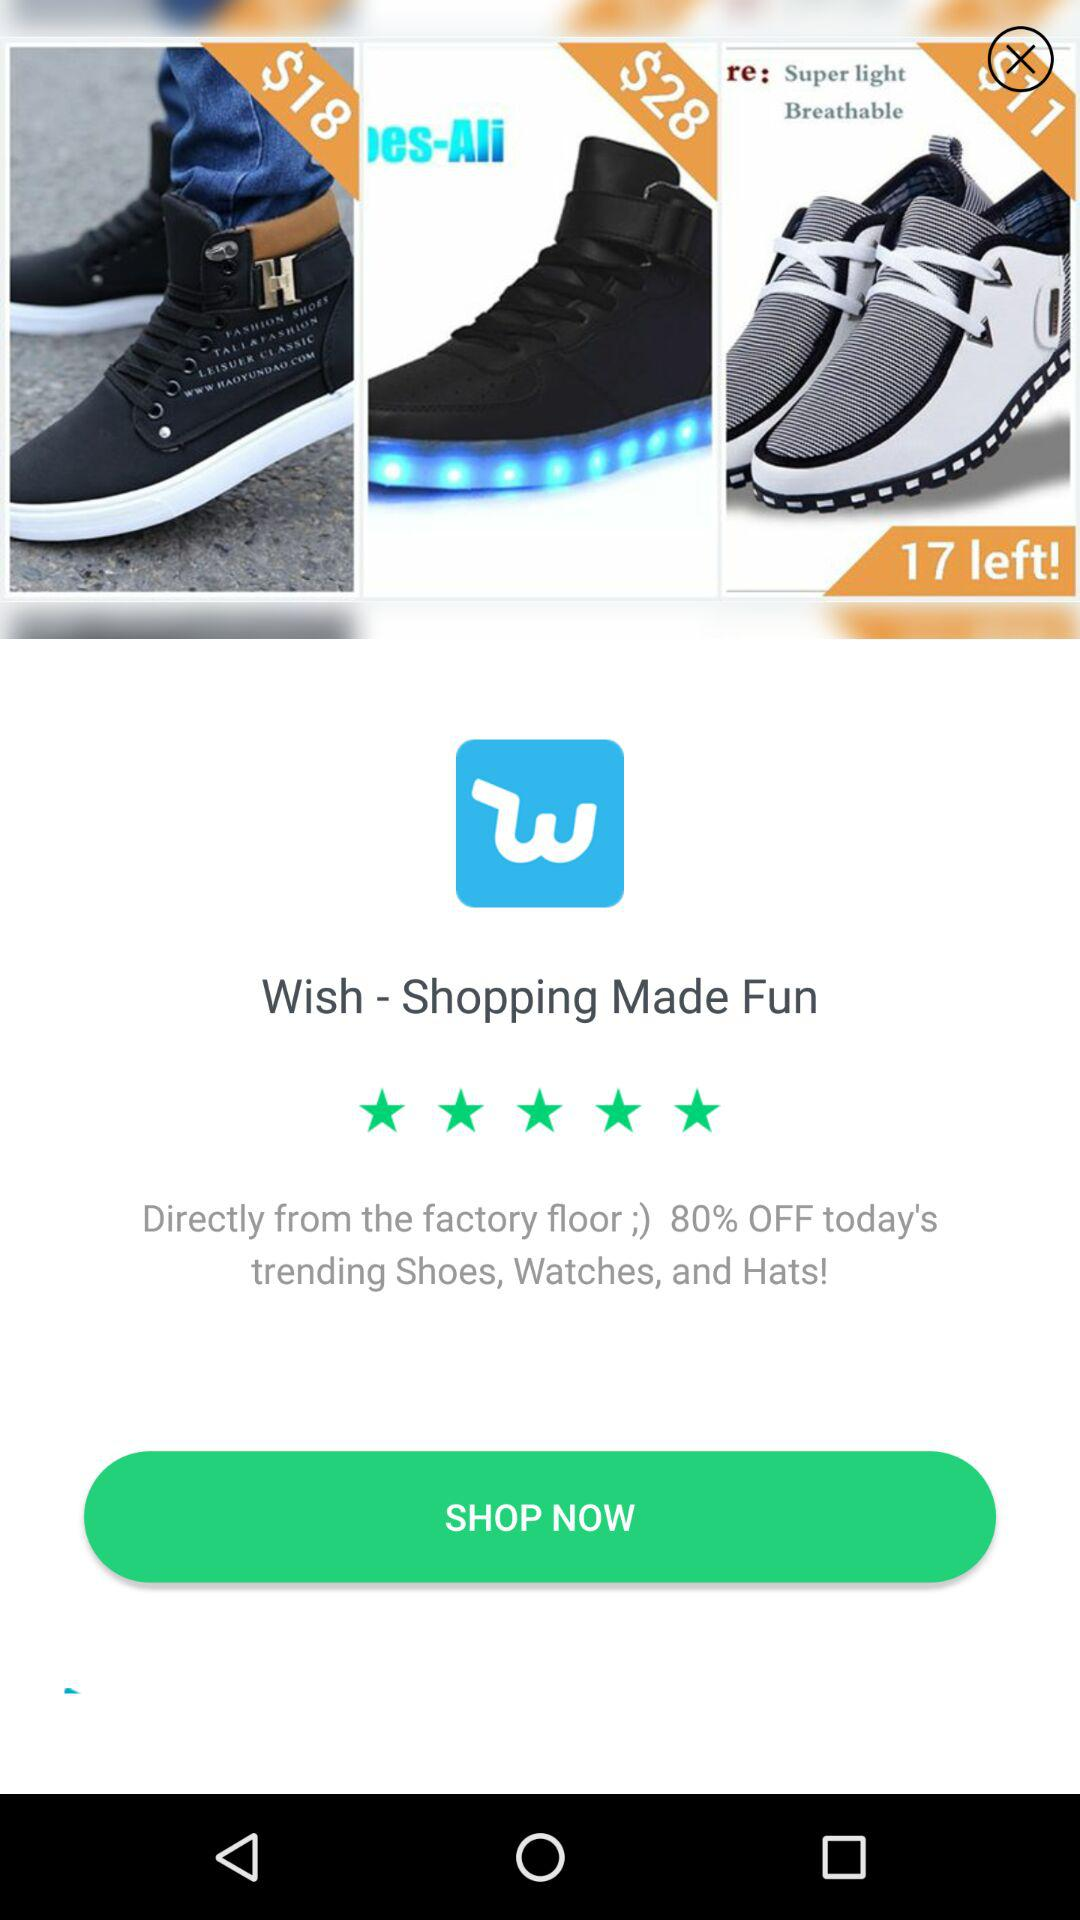How much percentage is off on today's trending shoes, watches and hats? There is an 80% off on today's trending shoes, watches and hats. 